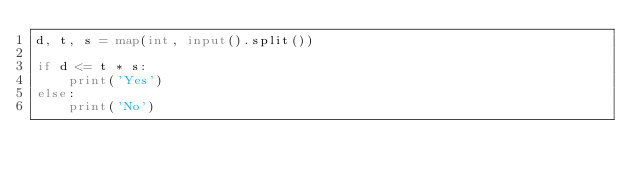<code> <loc_0><loc_0><loc_500><loc_500><_Python_>d, t, s = map(int, input().split())

if d <= t * s:
    print('Yes')
else:
    print('No')
</code> 